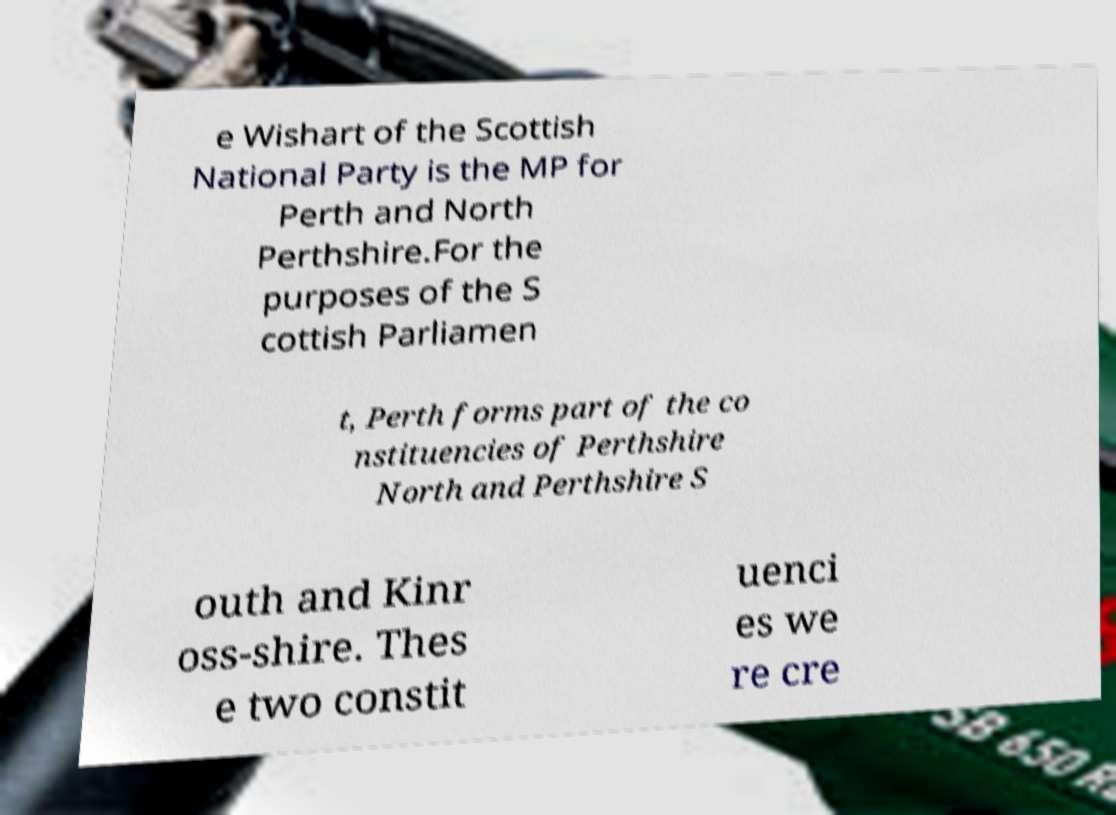I need the written content from this picture converted into text. Can you do that? e Wishart of the Scottish National Party is the MP for Perth and North Perthshire.For the purposes of the S cottish Parliamen t, Perth forms part of the co nstituencies of Perthshire North and Perthshire S outh and Kinr oss-shire. Thes e two constit uenci es we re cre 